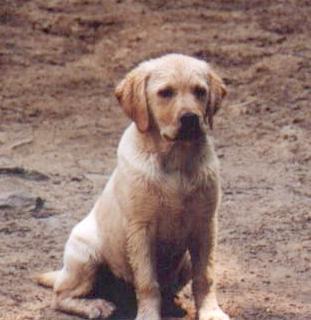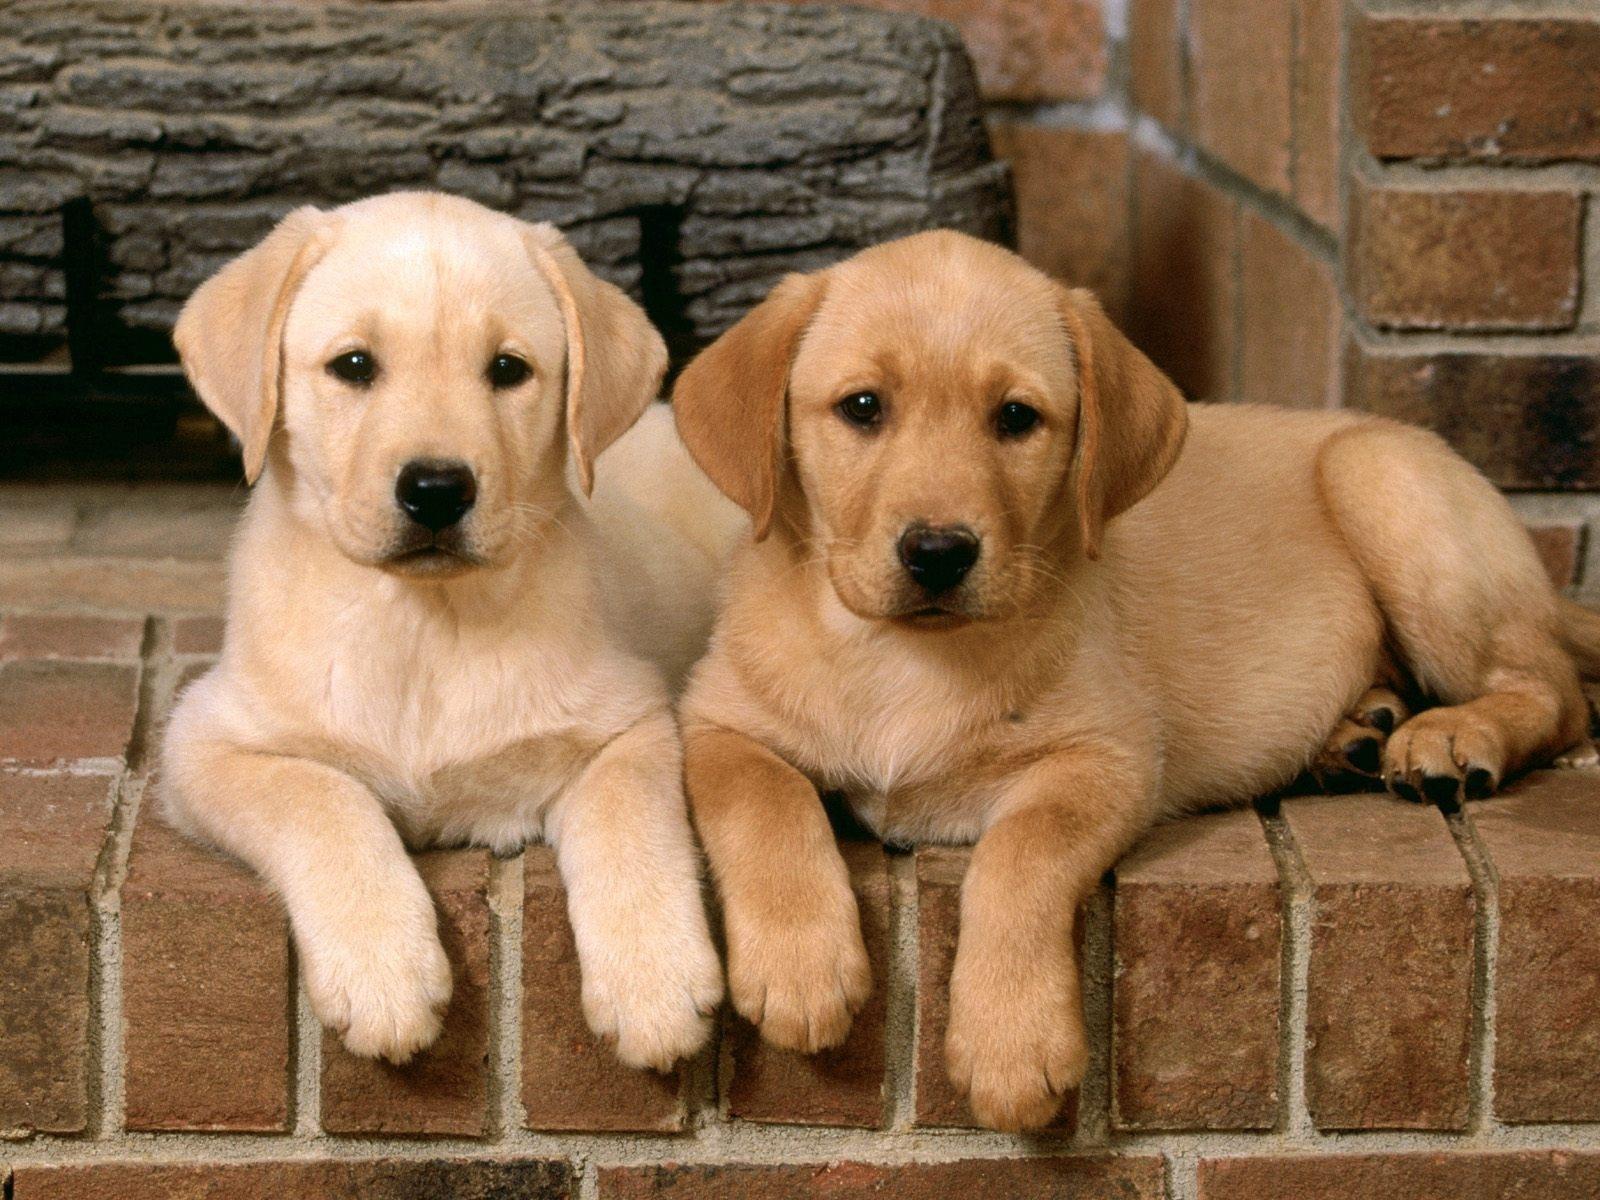The first image is the image on the left, the second image is the image on the right. For the images displayed, is the sentence "An image shows two beige pups and one black pup." factually correct? Answer yes or no. No. The first image is the image on the left, the second image is the image on the right. Assess this claim about the two images: "One of the images shows exactly three puppies.". Correct or not? Answer yes or no. No. 